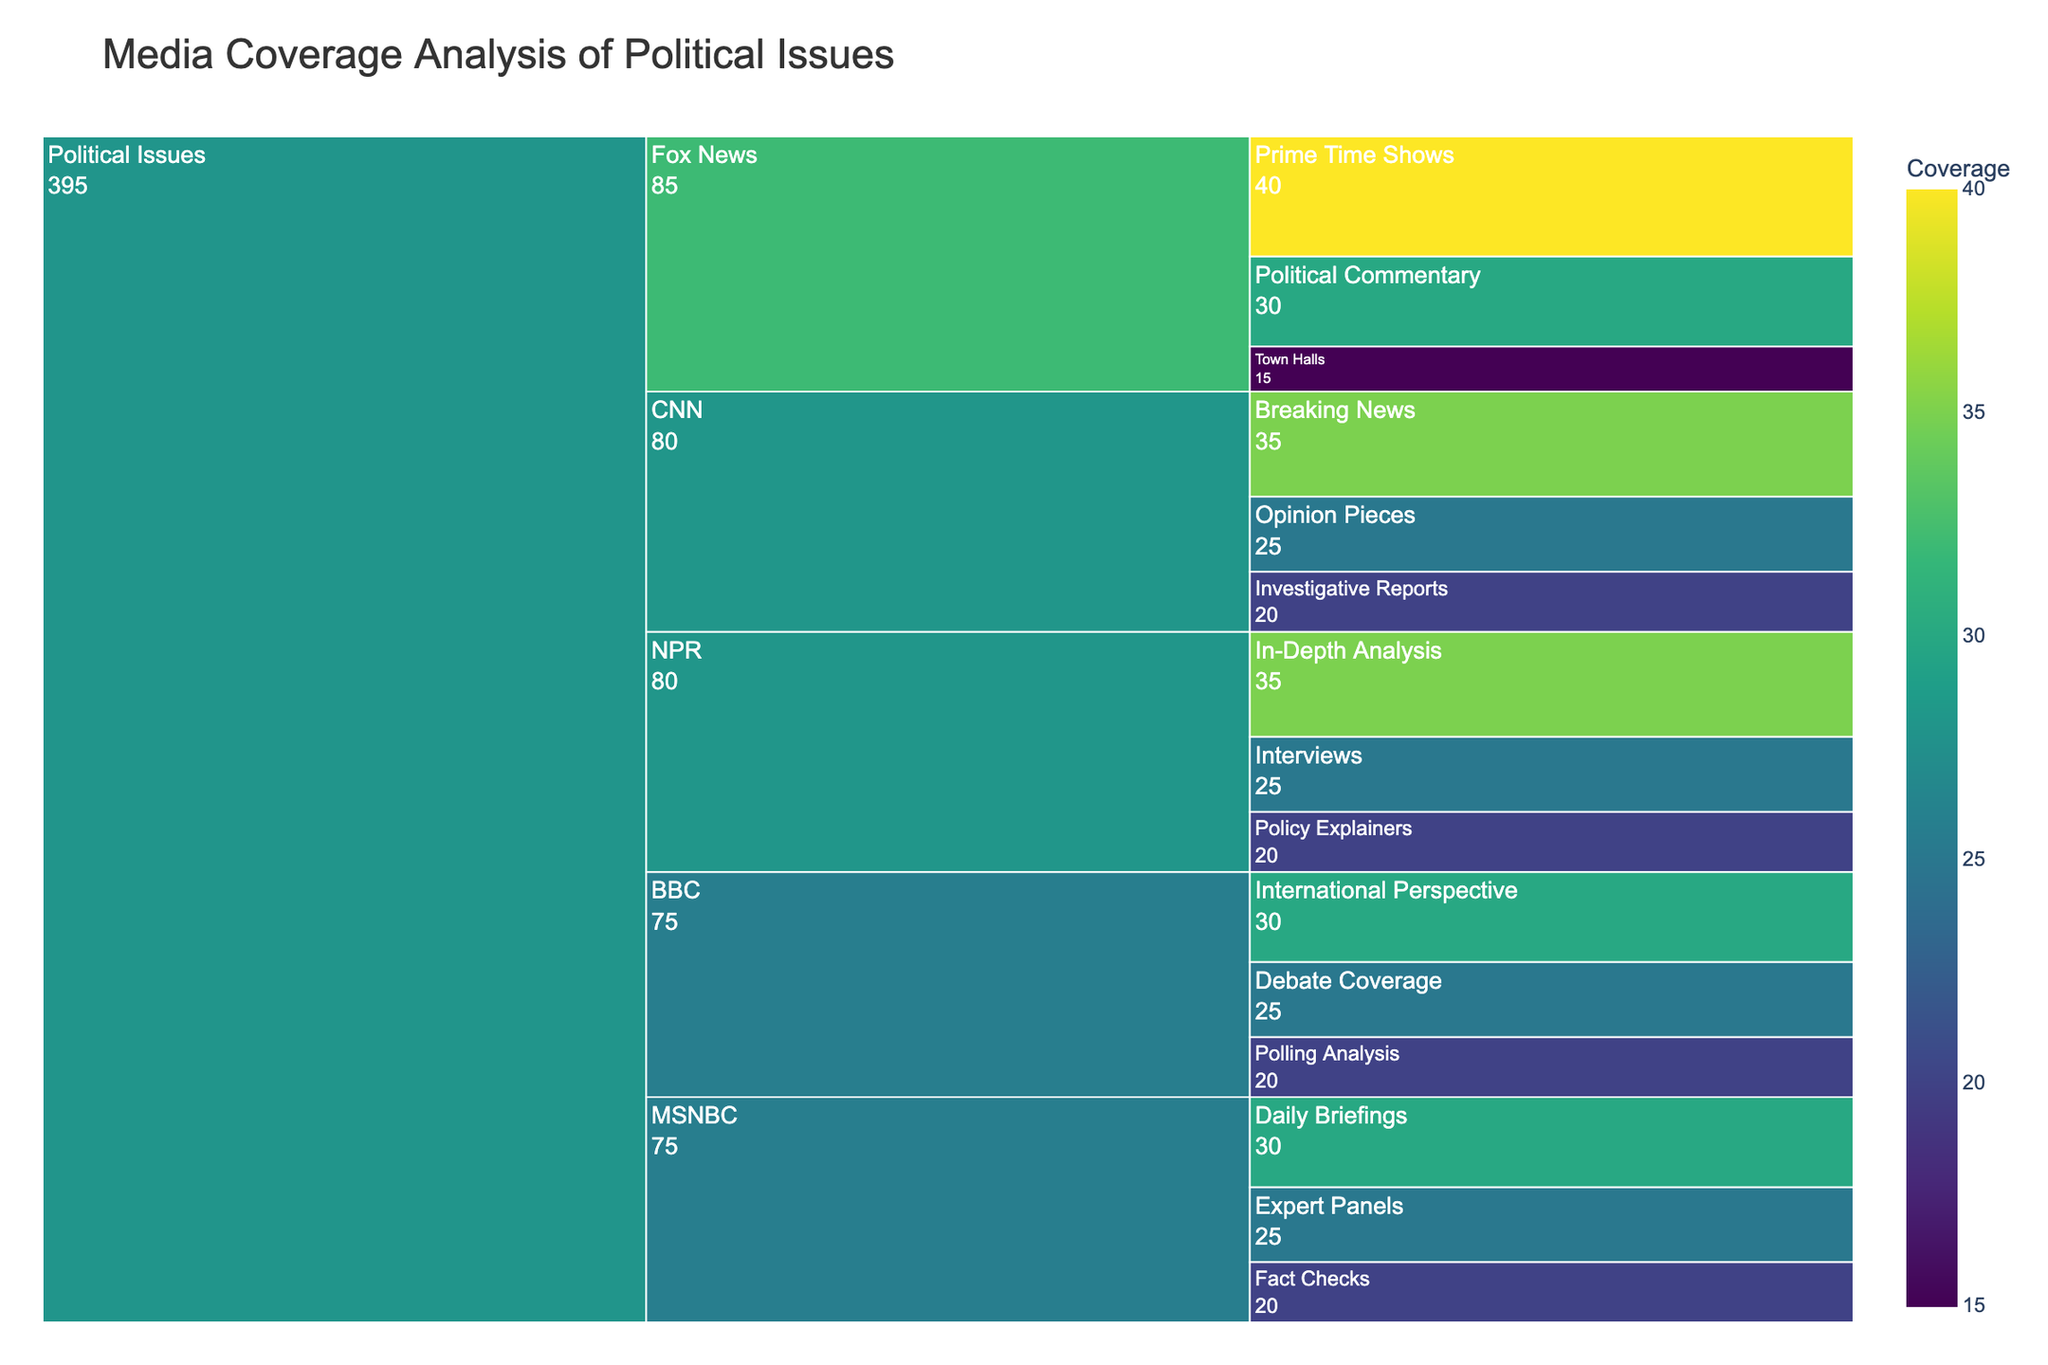What is the title of the chart? The title is always located at the top of the chart and provides a summary of the chart's content.
Answer: Media Coverage Analysis of Political Issues Which news outlet has the highest coverage in the category 'Political Commentary'? Find the segment labeled 'Political Commentary' within each news outlet and compare their coverage values. Fox News has a 'Political Commentary' coverage of 30, which is higher than any other outlet.
Answer: Fox News How much total coverage does CNN have from all its sub-categories? Identify all sub-categories under CNN and sum up their coverage values: Breaking News (35) + Opinion Pieces (25) + Investigative Reports (20) = 80.
Answer: 80 Which sub-category under NPR has the lowest coverage value? Look for sub-categories under NPR and compare their coverage values: In-Depth Analysis (35), Interviews (25), Policy Explainers (20). Policy Explainers has the lowest value.
Answer: Policy Explainers Compare the coverage of 'Daily Briefings' between MSNBC and any other news outlet's sub-category. Which one has higher coverage? MSNBC's 'Daily Briefings' has a coverage of 30. All other sub-categories in other news outlets for comparison are lower than 30.
Answer: MSNBC's Daily Briefings What is the combined coverage of 'Fact Checks' and 'Expert Panels' under MSNBC? Find the segments labeled 'Fact Checks' and 'Expert Panels' under MSNBC and add their coverage values: Fact Checks (20) + Expert Panels (25) = 45.
Answer: 45 Which news outlet has the most balanced (equal) distribution of coverage among its sub-categories for political issues? Identify the mean coverage for each outlet and check how close each sub-category value is to this mean. For NPR, the values are close: In-Depth Analysis (35), Interviews (25), Policy Explainers (20).
Answer: NPR In the context of the chart, which sub-category has the highest coverage value, and what is that value? Look for the highest coverage value within the sub-categories listed in the chart. Fox News' Prime Time Shows has the highest with a value of 40.
Answer: Prime Time Shows (40) What is the difference in coverage between 'International Perspective' and 'Debate Coverage' under BBC? Subtract the coverage value of 'Debate Coverage' from 'International Perspective': International Perspective (30) - Debate Coverage (25) = 5.
Answer: 5 